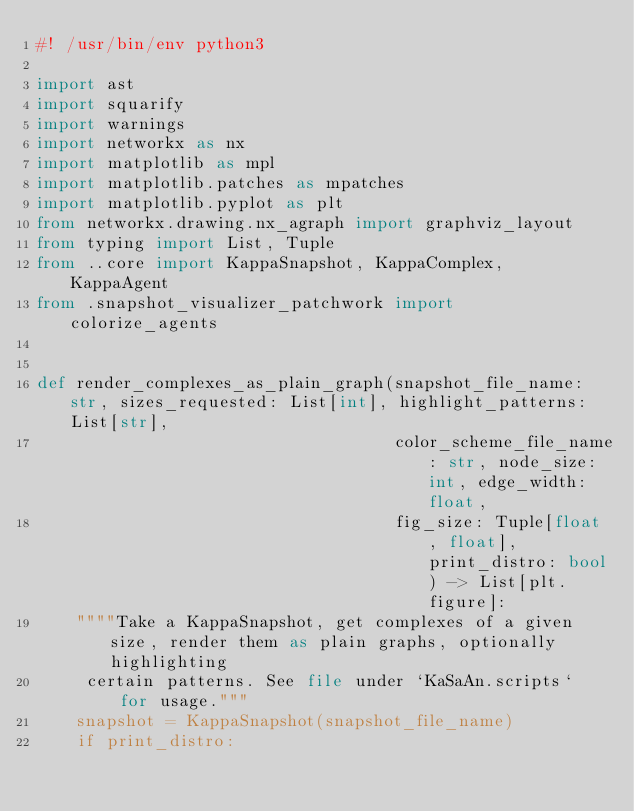Convert code to text. <code><loc_0><loc_0><loc_500><loc_500><_Python_>#! /usr/bin/env python3

import ast
import squarify
import warnings
import networkx as nx
import matplotlib as mpl
import matplotlib.patches as mpatches
import matplotlib.pyplot as plt
from networkx.drawing.nx_agraph import graphviz_layout
from typing import List, Tuple
from ..core import KappaSnapshot, KappaComplex, KappaAgent
from .snapshot_visualizer_patchwork import colorize_agents


def render_complexes_as_plain_graph(snapshot_file_name: str, sizes_requested: List[int], highlight_patterns: List[str],
                                    color_scheme_file_name: str, node_size: int, edge_width: float,
                                    fig_size: Tuple[float, float], print_distro: bool) -> List[plt.figure]:
    """"Take a KappaSnapshot, get complexes of a given size, render them as plain graphs, optionally highlighting
     certain patterns. See file under `KaSaAn.scripts` for usage."""
    snapshot = KappaSnapshot(snapshot_file_name)
    if print_distro:</code> 